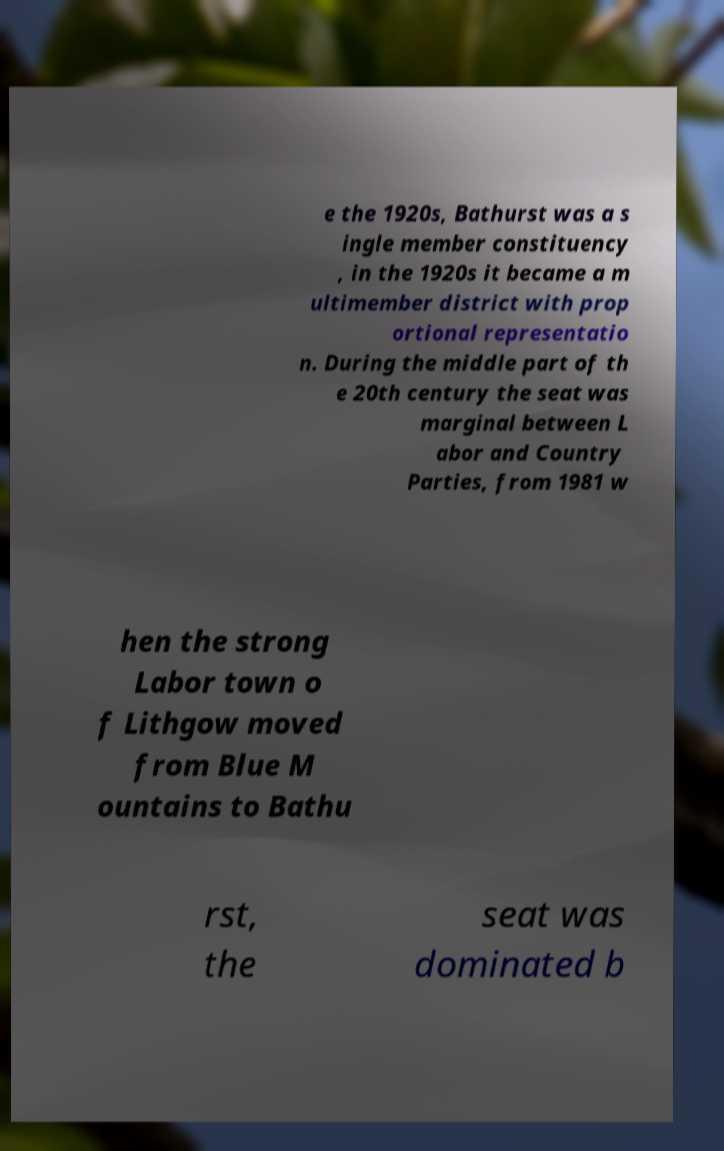For documentation purposes, I need the text within this image transcribed. Could you provide that? e the 1920s, Bathurst was a s ingle member constituency , in the 1920s it became a m ultimember district with prop ortional representatio n. During the middle part of th e 20th century the seat was marginal between L abor and Country Parties, from 1981 w hen the strong Labor town o f Lithgow moved from Blue M ountains to Bathu rst, the seat was dominated b 